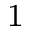Convert formula to latex. <formula><loc_0><loc_0><loc_500><loc_500>_ { 1 }</formula> 